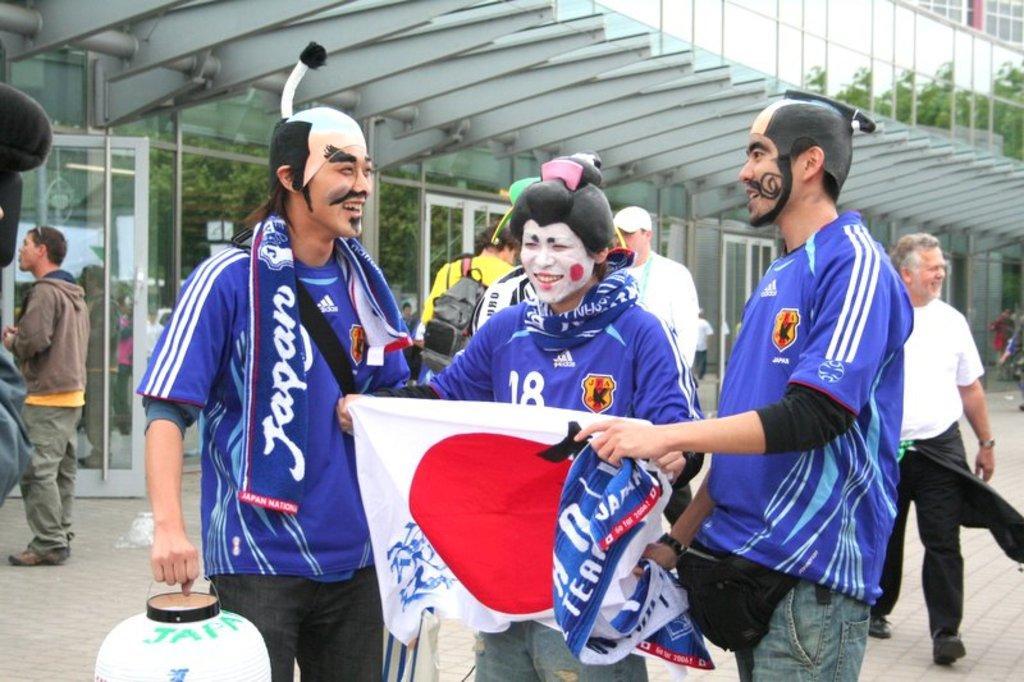Describe this image in one or two sentences. In this image, we can see few people. Three persons are holding some objects and smiling. Background we can see glass objects and trees. 